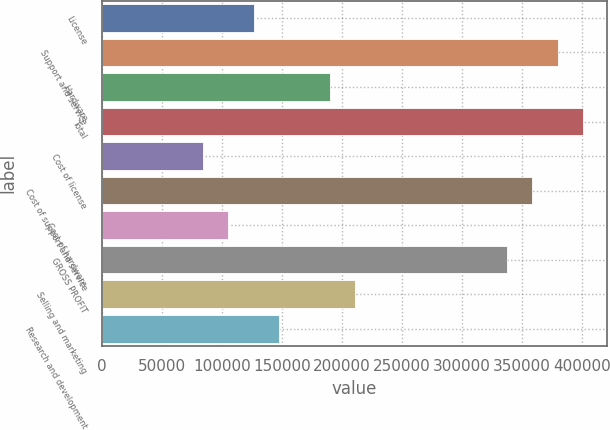Convert chart to OTSL. <chart><loc_0><loc_0><loc_500><loc_500><bar_chart><fcel>License<fcel>Support and service<fcel>Hardware<fcel>Total<fcel>Cost of license<fcel>Cost of support and service<fcel>Cost of hardware<fcel>GROSS PROFIT<fcel>Selling and marketing<fcel>Research and development<nl><fcel>126517<fcel>379549<fcel>189775<fcel>400636<fcel>84344.6<fcel>358463<fcel>105431<fcel>337377<fcel>210861<fcel>147603<nl></chart> 